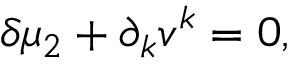<formula> <loc_0><loc_0><loc_500><loc_500>\delta \mu _ { 2 } + \partial _ { k } v ^ { k } = 0 ,</formula> 